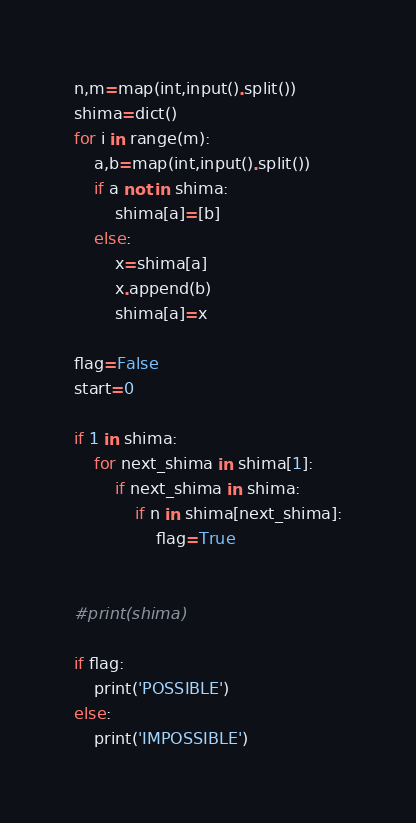<code> <loc_0><loc_0><loc_500><loc_500><_Python_>n,m=map(int,input().split())
shima=dict()
for i in range(m):
    a,b=map(int,input().split())
    if a not in shima:
        shima[a]=[b]
    else:
        x=shima[a]
        x.append(b)
        shima[a]=x

flag=False
start=0

if 1 in shima:
    for next_shima in shima[1]:
        if next_shima in shima:
            if n in shima[next_shima]:
                flag=True 


#print(shima)

if flag:
    print('POSSIBLE')
else:
    print('IMPOSSIBLE')
</code> 